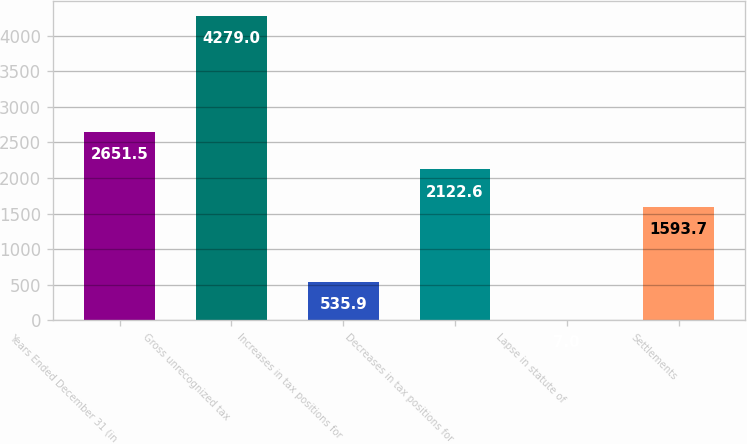Convert chart. <chart><loc_0><loc_0><loc_500><loc_500><bar_chart><fcel>Years Ended December 31 (in<fcel>Gross unrecognized tax<fcel>Increases in tax positions for<fcel>Decreases in tax positions for<fcel>Lapse in statute of<fcel>Settlements<nl><fcel>2651.5<fcel>4279<fcel>535.9<fcel>2122.6<fcel>7<fcel>1593.7<nl></chart> 